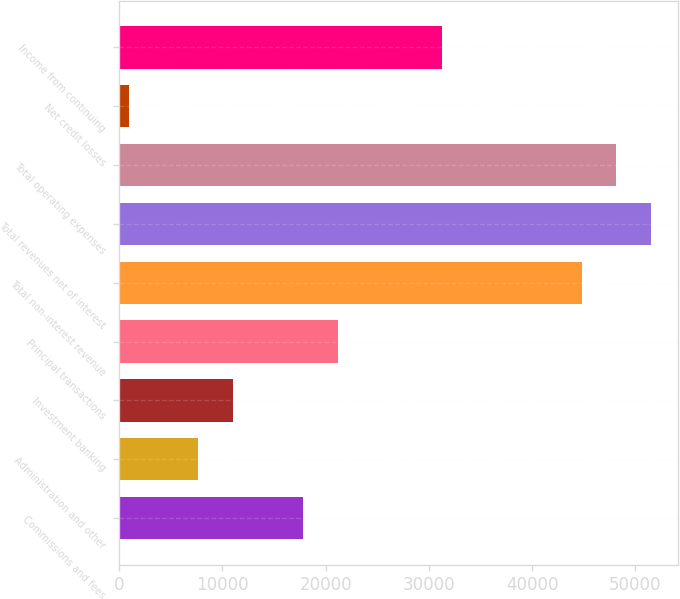<chart> <loc_0><loc_0><loc_500><loc_500><bar_chart><fcel>Commissions and fees<fcel>Administration and other<fcel>Investment banking<fcel>Principal transactions<fcel>Total non-interest revenue<fcel>Total revenues net of interest<fcel>Total operating expenses<fcel>Net credit losses<fcel>Income from continuing<nl><fcel>17795<fcel>7667.6<fcel>11043.4<fcel>21170.8<fcel>44801.4<fcel>51553<fcel>48177.2<fcel>916<fcel>31298.2<nl></chart> 